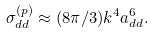Convert formula to latex. <formula><loc_0><loc_0><loc_500><loc_500>\sigma _ { d d } ^ { ( p ) } \approx ( 8 \pi / 3 ) k ^ { 4 } a _ { d d } ^ { 6 } .</formula> 